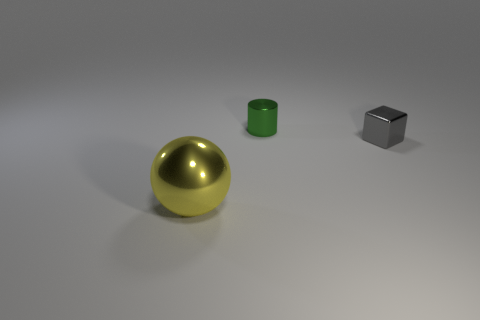Is there anything else that is the same size as the yellow ball?
Provide a short and direct response. No. Are there any cylinders that have the same material as the small green thing?
Your answer should be very brief. No. How many cylinders are small green shiny things or metallic things?
Your response must be concise. 1. There is a tiny metallic thing that is in front of the cylinder; is there a tiny shiny object that is behind it?
Provide a short and direct response. Yes. Is the number of tiny metallic blocks less than the number of small shiny things?
Ensure brevity in your answer.  Yes. How many other things are the same shape as the small gray thing?
Provide a short and direct response. 0. How many purple objects are tiny objects or spheres?
Offer a terse response. 0. What is the size of the metal object that is in front of the tiny metal thing right of the green cylinder?
Provide a succinct answer. Large. What number of gray shiny objects are the same size as the green metallic cylinder?
Ensure brevity in your answer.  1. Do the gray shiny thing and the cylinder have the same size?
Give a very brief answer. Yes. 